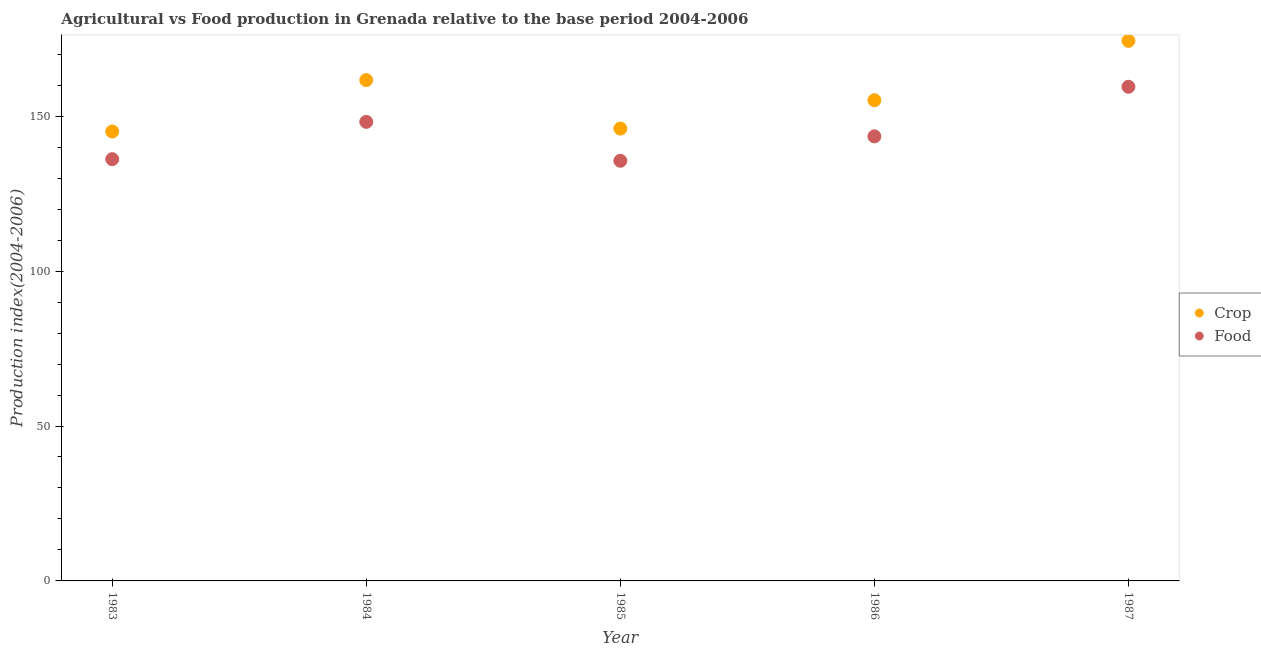What is the crop production index in 1983?
Provide a short and direct response. 145.05. Across all years, what is the maximum crop production index?
Make the answer very short. 174.31. Across all years, what is the minimum food production index?
Your answer should be very brief. 135.61. In which year was the food production index maximum?
Keep it short and to the point. 1987. In which year was the food production index minimum?
Provide a short and direct response. 1985. What is the total crop production index in the graph?
Your answer should be very brief. 782.18. What is the difference between the crop production index in 1985 and that in 1986?
Provide a short and direct response. -9.15. What is the difference between the crop production index in 1985 and the food production index in 1986?
Make the answer very short. 2.52. What is the average crop production index per year?
Make the answer very short. 156.44. In the year 1984, what is the difference between the crop production index and food production index?
Offer a terse response. 13.48. In how many years, is the food production index greater than 110?
Provide a short and direct response. 5. What is the ratio of the food production index in 1985 to that in 1987?
Your response must be concise. 0.85. Is the difference between the food production index in 1986 and 1987 greater than the difference between the crop production index in 1986 and 1987?
Your answer should be compact. Yes. What is the difference between the highest and the second highest crop production index?
Make the answer very short. 12.66. What is the difference between the highest and the lowest food production index?
Your answer should be compact. 23.88. Is the sum of the crop production index in 1985 and 1987 greater than the maximum food production index across all years?
Your response must be concise. Yes. Is the crop production index strictly greater than the food production index over the years?
Give a very brief answer. Yes. Is the crop production index strictly less than the food production index over the years?
Offer a terse response. No. How many dotlines are there?
Your response must be concise. 2. What is the difference between two consecutive major ticks on the Y-axis?
Keep it short and to the point. 50. Are the values on the major ticks of Y-axis written in scientific E-notation?
Ensure brevity in your answer.  No. Does the graph contain any zero values?
Offer a terse response. No. Does the graph contain grids?
Provide a succinct answer. No. Where does the legend appear in the graph?
Your answer should be very brief. Center right. How many legend labels are there?
Make the answer very short. 2. What is the title of the graph?
Keep it short and to the point. Agricultural vs Food production in Grenada relative to the base period 2004-2006. What is the label or title of the X-axis?
Your response must be concise. Year. What is the label or title of the Y-axis?
Ensure brevity in your answer.  Production index(2004-2006). What is the Production index(2004-2006) in Crop in 1983?
Offer a very short reply. 145.05. What is the Production index(2004-2006) of Food in 1983?
Your answer should be compact. 136.13. What is the Production index(2004-2006) of Crop in 1984?
Make the answer very short. 161.65. What is the Production index(2004-2006) of Food in 1984?
Provide a short and direct response. 148.17. What is the Production index(2004-2006) of Crop in 1985?
Your answer should be compact. 146.01. What is the Production index(2004-2006) in Food in 1985?
Provide a succinct answer. 135.61. What is the Production index(2004-2006) of Crop in 1986?
Offer a very short reply. 155.16. What is the Production index(2004-2006) of Food in 1986?
Give a very brief answer. 143.49. What is the Production index(2004-2006) of Crop in 1987?
Provide a short and direct response. 174.31. What is the Production index(2004-2006) of Food in 1987?
Offer a very short reply. 159.49. Across all years, what is the maximum Production index(2004-2006) in Crop?
Ensure brevity in your answer.  174.31. Across all years, what is the maximum Production index(2004-2006) in Food?
Your answer should be compact. 159.49. Across all years, what is the minimum Production index(2004-2006) of Crop?
Keep it short and to the point. 145.05. Across all years, what is the minimum Production index(2004-2006) of Food?
Offer a terse response. 135.61. What is the total Production index(2004-2006) in Crop in the graph?
Offer a terse response. 782.18. What is the total Production index(2004-2006) of Food in the graph?
Keep it short and to the point. 722.89. What is the difference between the Production index(2004-2006) in Crop in 1983 and that in 1984?
Provide a short and direct response. -16.6. What is the difference between the Production index(2004-2006) in Food in 1983 and that in 1984?
Offer a very short reply. -12.04. What is the difference between the Production index(2004-2006) in Crop in 1983 and that in 1985?
Provide a short and direct response. -0.96. What is the difference between the Production index(2004-2006) of Food in 1983 and that in 1985?
Your answer should be compact. 0.52. What is the difference between the Production index(2004-2006) of Crop in 1983 and that in 1986?
Give a very brief answer. -10.11. What is the difference between the Production index(2004-2006) in Food in 1983 and that in 1986?
Your answer should be compact. -7.36. What is the difference between the Production index(2004-2006) of Crop in 1983 and that in 1987?
Offer a very short reply. -29.26. What is the difference between the Production index(2004-2006) of Food in 1983 and that in 1987?
Keep it short and to the point. -23.36. What is the difference between the Production index(2004-2006) of Crop in 1984 and that in 1985?
Provide a succinct answer. 15.64. What is the difference between the Production index(2004-2006) in Food in 1984 and that in 1985?
Ensure brevity in your answer.  12.56. What is the difference between the Production index(2004-2006) in Crop in 1984 and that in 1986?
Provide a short and direct response. 6.49. What is the difference between the Production index(2004-2006) in Food in 1984 and that in 1986?
Ensure brevity in your answer.  4.68. What is the difference between the Production index(2004-2006) of Crop in 1984 and that in 1987?
Offer a terse response. -12.66. What is the difference between the Production index(2004-2006) in Food in 1984 and that in 1987?
Provide a short and direct response. -11.32. What is the difference between the Production index(2004-2006) in Crop in 1985 and that in 1986?
Your response must be concise. -9.15. What is the difference between the Production index(2004-2006) in Food in 1985 and that in 1986?
Ensure brevity in your answer.  -7.88. What is the difference between the Production index(2004-2006) in Crop in 1985 and that in 1987?
Make the answer very short. -28.3. What is the difference between the Production index(2004-2006) of Food in 1985 and that in 1987?
Your answer should be very brief. -23.88. What is the difference between the Production index(2004-2006) of Crop in 1986 and that in 1987?
Make the answer very short. -19.15. What is the difference between the Production index(2004-2006) in Food in 1986 and that in 1987?
Your answer should be compact. -16. What is the difference between the Production index(2004-2006) in Crop in 1983 and the Production index(2004-2006) in Food in 1984?
Give a very brief answer. -3.12. What is the difference between the Production index(2004-2006) in Crop in 1983 and the Production index(2004-2006) in Food in 1985?
Keep it short and to the point. 9.44. What is the difference between the Production index(2004-2006) of Crop in 1983 and the Production index(2004-2006) of Food in 1986?
Give a very brief answer. 1.56. What is the difference between the Production index(2004-2006) in Crop in 1983 and the Production index(2004-2006) in Food in 1987?
Offer a terse response. -14.44. What is the difference between the Production index(2004-2006) of Crop in 1984 and the Production index(2004-2006) of Food in 1985?
Your response must be concise. 26.04. What is the difference between the Production index(2004-2006) in Crop in 1984 and the Production index(2004-2006) in Food in 1986?
Your answer should be compact. 18.16. What is the difference between the Production index(2004-2006) in Crop in 1984 and the Production index(2004-2006) in Food in 1987?
Your answer should be compact. 2.16. What is the difference between the Production index(2004-2006) of Crop in 1985 and the Production index(2004-2006) of Food in 1986?
Your response must be concise. 2.52. What is the difference between the Production index(2004-2006) in Crop in 1985 and the Production index(2004-2006) in Food in 1987?
Make the answer very short. -13.48. What is the difference between the Production index(2004-2006) in Crop in 1986 and the Production index(2004-2006) in Food in 1987?
Your answer should be compact. -4.33. What is the average Production index(2004-2006) of Crop per year?
Keep it short and to the point. 156.44. What is the average Production index(2004-2006) of Food per year?
Provide a short and direct response. 144.58. In the year 1983, what is the difference between the Production index(2004-2006) in Crop and Production index(2004-2006) in Food?
Keep it short and to the point. 8.92. In the year 1984, what is the difference between the Production index(2004-2006) in Crop and Production index(2004-2006) in Food?
Make the answer very short. 13.48. In the year 1985, what is the difference between the Production index(2004-2006) in Crop and Production index(2004-2006) in Food?
Ensure brevity in your answer.  10.4. In the year 1986, what is the difference between the Production index(2004-2006) of Crop and Production index(2004-2006) of Food?
Provide a succinct answer. 11.67. In the year 1987, what is the difference between the Production index(2004-2006) of Crop and Production index(2004-2006) of Food?
Give a very brief answer. 14.82. What is the ratio of the Production index(2004-2006) in Crop in 1983 to that in 1984?
Your response must be concise. 0.9. What is the ratio of the Production index(2004-2006) in Food in 1983 to that in 1984?
Give a very brief answer. 0.92. What is the ratio of the Production index(2004-2006) in Food in 1983 to that in 1985?
Offer a very short reply. 1. What is the ratio of the Production index(2004-2006) in Crop in 1983 to that in 1986?
Give a very brief answer. 0.93. What is the ratio of the Production index(2004-2006) in Food in 1983 to that in 1986?
Your response must be concise. 0.95. What is the ratio of the Production index(2004-2006) in Crop in 1983 to that in 1987?
Your answer should be very brief. 0.83. What is the ratio of the Production index(2004-2006) in Food in 1983 to that in 1987?
Your response must be concise. 0.85. What is the ratio of the Production index(2004-2006) in Crop in 1984 to that in 1985?
Offer a terse response. 1.11. What is the ratio of the Production index(2004-2006) of Food in 1984 to that in 1985?
Offer a very short reply. 1.09. What is the ratio of the Production index(2004-2006) of Crop in 1984 to that in 1986?
Your answer should be compact. 1.04. What is the ratio of the Production index(2004-2006) of Food in 1984 to that in 1986?
Give a very brief answer. 1.03. What is the ratio of the Production index(2004-2006) of Crop in 1984 to that in 1987?
Keep it short and to the point. 0.93. What is the ratio of the Production index(2004-2006) in Food in 1984 to that in 1987?
Offer a terse response. 0.93. What is the ratio of the Production index(2004-2006) of Crop in 1985 to that in 1986?
Offer a very short reply. 0.94. What is the ratio of the Production index(2004-2006) in Food in 1985 to that in 1986?
Offer a terse response. 0.95. What is the ratio of the Production index(2004-2006) in Crop in 1985 to that in 1987?
Ensure brevity in your answer.  0.84. What is the ratio of the Production index(2004-2006) of Food in 1985 to that in 1987?
Your response must be concise. 0.85. What is the ratio of the Production index(2004-2006) in Crop in 1986 to that in 1987?
Ensure brevity in your answer.  0.89. What is the ratio of the Production index(2004-2006) of Food in 1986 to that in 1987?
Provide a succinct answer. 0.9. What is the difference between the highest and the second highest Production index(2004-2006) in Crop?
Offer a terse response. 12.66. What is the difference between the highest and the second highest Production index(2004-2006) of Food?
Offer a very short reply. 11.32. What is the difference between the highest and the lowest Production index(2004-2006) in Crop?
Ensure brevity in your answer.  29.26. What is the difference between the highest and the lowest Production index(2004-2006) in Food?
Offer a terse response. 23.88. 